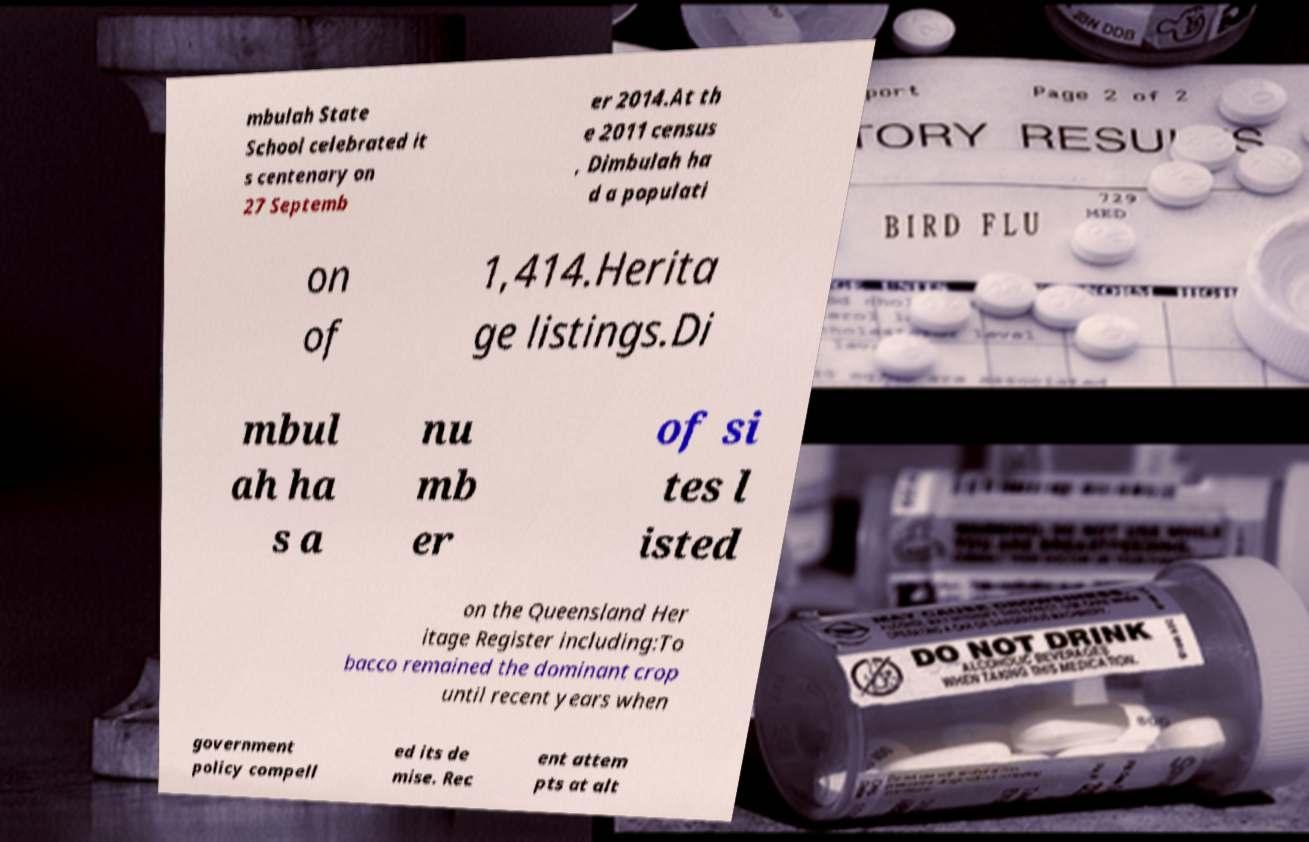Can you read and provide the text displayed in the image?This photo seems to have some interesting text. Can you extract and type it out for me? mbulah State School celebrated it s centenary on 27 Septemb er 2014.At th e 2011 census , Dimbulah ha d a populati on of 1,414.Herita ge listings.Di mbul ah ha s a nu mb er of si tes l isted on the Queensland Her itage Register including:To bacco remained the dominant crop until recent years when government policy compell ed its de mise. Rec ent attem pts at alt 